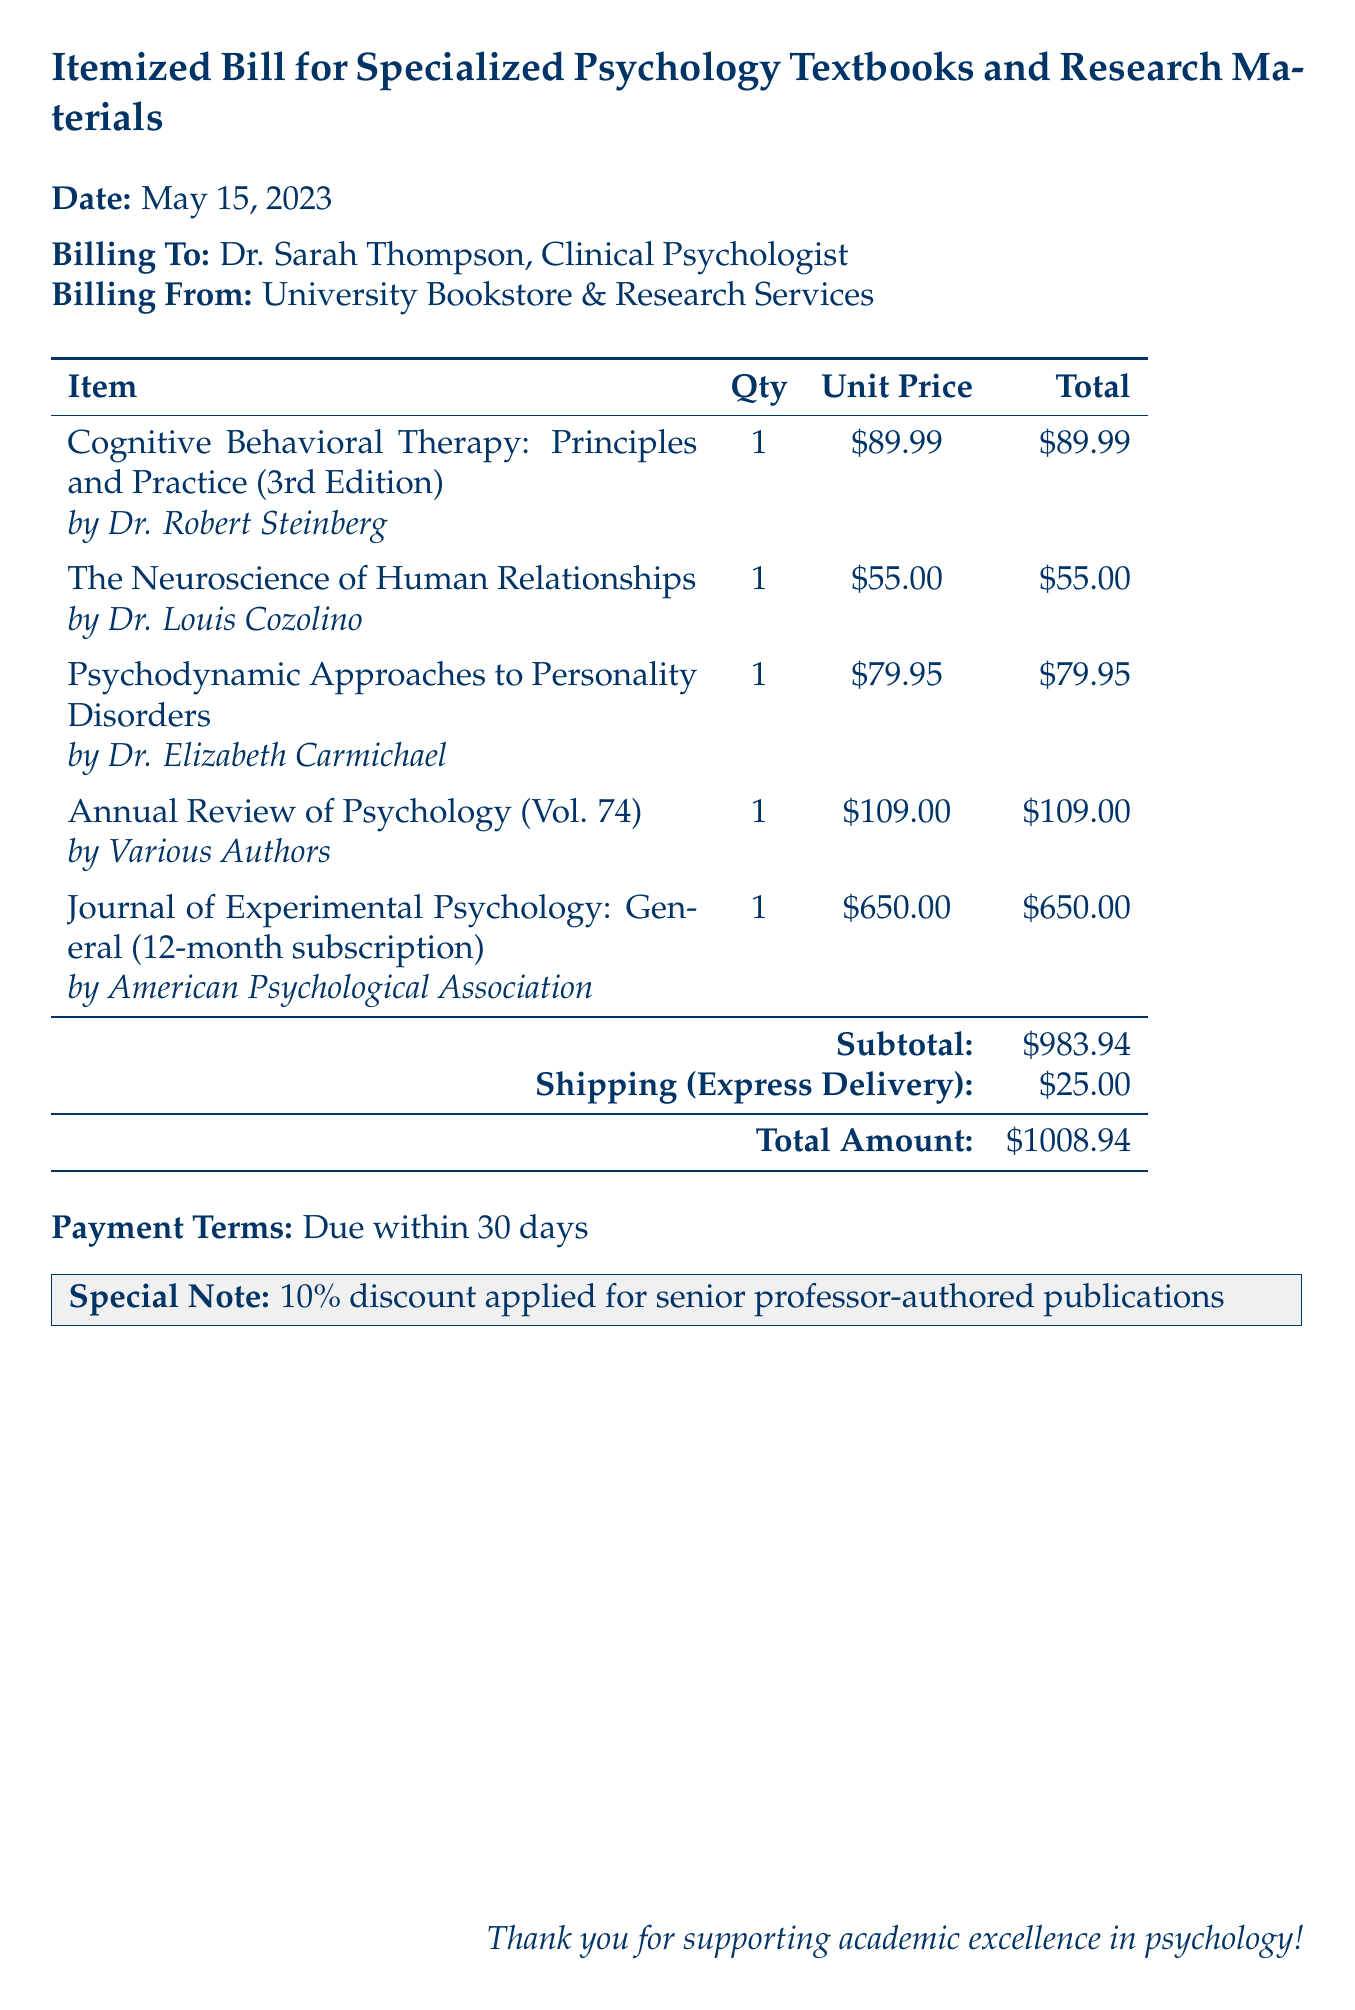What is the date of the bill? The date of the bill is specified at the top of the document as May 15, 2023.
Answer: May 15, 2023 Who is billed for the textbook order? The document specifies that the billing is to Dr. Sarah Thompson, Clinical Psychologist.
Answer: Dr. Sarah Thompson What is the total amount due? The total amount due is presented at the bottom of the itemized bill.
Answer: $1008.94 What is the shipping cost? The shipping cost is explicitly stated in the document under "Shipping (Express Delivery)."
Answer: $25.00 Which publication has a subscription listed? The document indicates a subscription for the Journal of Experimental Psychology: General.
Answer: Journal of Experimental Psychology: General How many textbooks authored by senior professors are included? The document lists the specific textbooks authored by senior professors.
Answer: 3 What discount is applied for senior professor-authored publications? The special note at the bottom mentions the 10% discount applied.
Answer: 10% What is the subtotal amount before shipping? The subtotal amount before shipping costs is detailed in the document.
Answer: $983.94 Which publication is the most expensive? The item with the highest price in the itemized list is the Journal of Experimental Psychology: General subscription.
Answer: Journal of Experimental Psychology: General 